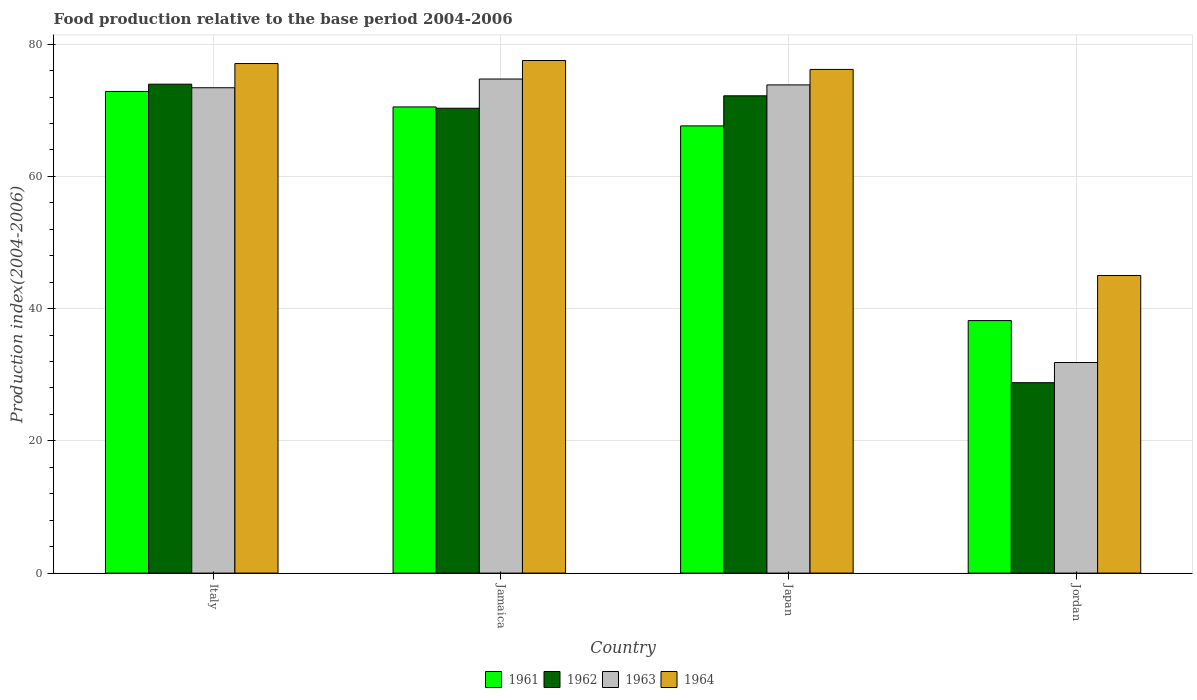How many different coloured bars are there?
Offer a terse response. 4. What is the label of the 1st group of bars from the left?
Make the answer very short. Italy. What is the food production index in 1962 in Italy?
Provide a short and direct response. 73.95. Across all countries, what is the maximum food production index in 1961?
Your response must be concise. 72.85. Across all countries, what is the minimum food production index in 1961?
Your response must be concise. 38.19. In which country was the food production index in 1963 maximum?
Your answer should be very brief. Jamaica. In which country was the food production index in 1962 minimum?
Make the answer very short. Jordan. What is the total food production index in 1961 in the graph?
Provide a short and direct response. 249.19. What is the difference between the food production index in 1961 in Japan and that in Jordan?
Ensure brevity in your answer.  29.45. What is the difference between the food production index in 1961 in Italy and the food production index in 1964 in Jordan?
Provide a short and direct response. 27.84. What is the average food production index in 1961 per country?
Provide a succinct answer. 62.3. What is the difference between the food production index of/in 1962 and food production index of/in 1964 in Japan?
Ensure brevity in your answer.  -3.99. What is the ratio of the food production index in 1962 in Italy to that in Jordan?
Ensure brevity in your answer.  2.57. Is the food production index in 1963 in Japan less than that in Jordan?
Provide a short and direct response. No. What is the difference between the highest and the second highest food production index in 1963?
Offer a very short reply. -0.43. What is the difference between the highest and the lowest food production index in 1963?
Keep it short and to the point. 42.88. In how many countries, is the food production index in 1963 greater than the average food production index in 1963 taken over all countries?
Your answer should be very brief. 3. Is the sum of the food production index in 1961 in Italy and Jordan greater than the maximum food production index in 1964 across all countries?
Offer a very short reply. Yes. Is it the case that in every country, the sum of the food production index in 1962 and food production index in 1961 is greater than the sum of food production index in 1963 and food production index in 1964?
Your answer should be compact. No. What does the 1st bar from the left in Jamaica represents?
Offer a very short reply. 1961. Is it the case that in every country, the sum of the food production index in 1962 and food production index in 1964 is greater than the food production index in 1961?
Ensure brevity in your answer.  Yes. How many bars are there?
Make the answer very short. 16. How many countries are there in the graph?
Ensure brevity in your answer.  4. Does the graph contain any zero values?
Ensure brevity in your answer.  No. Where does the legend appear in the graph?
Ensure brevity in your answer.  Bottom center. How many legend labels are there?
Your answer should be very brief. 4. How are the legend labels stacked?
Offer a very short reply. Horizontal. What is the title of the graph?
Provide a short and direct response. Food production relative to the base period 2004-2006. Does "2009" appear as one of the legend labels in the graph?
Give a very brief answer. No. What is the label or title of the X-axis?
Keep it short and to the point. Country. What is the label or title of the Y-axis?
Ensure brevity in your answer.  Production index(2004-2006). What is the Production index(2004-2006) of 1961 in Italy?
Give a very brief answer. 72.85. What is the Production index(2004-2006) in 1962 in Italy?
Offer a very short reply. 73.95. What is the Production index(2004-2006) in 1963 in Italy?
Your response must be concise. 73.41. What is the Production index(2004-2006) of 1964 in Italy?
Give a very brief answer. 77.07. What is the Production index(2004-2006) of 1961 in Jamaica?
Your answer should be very brief. 70.51. What is the Production index(2004-2006) in 1962 in Jamaica?
Keep it short and to the point. 70.31. What is the Production index(2004-2006) in 1963 in Jamaica?
Offer a very short reply. 74.73. What is the Production index(2004-2006) of 1964 in Jamaica?
Give a very brief answer. 77.53. What is the Production index(2004-2006) of 1961 in Japan?
Offer a terse response. 67.64. What is the Production index(2004-2006) in 1962 in Japan?
Keep it short and to the point. 72.19. What is the Production index(2004-2006) of 1963 in Japan?
Your response must be concise. 73.84. What is the Production index(2004-2006) of 1964 in Japan?
Your response must be concise. 76.18. What is the Production index(2004-2006) of 1961 in Jordan?
Give a very brief answer. 38.19. What is the Production index(2004-2006) in 1962 in Jordan?
Your response must be concise. 28.8. What is the Production index(2004-2006) in 1963 in Jordan?
Provide a short and direct response. 31.85. What is the Production index(2004-2006) of 1964 in Jordan?
Keep it short and to the point. 45.01. Across all countries, what is the maximum Production index(2004-2006) of 1961?
Your answer should be compact. 72.85. Across all countries, what is the maximum Production index(2004-2006) in 1962?
Keep it short and to the point. 73.95. Across all countries, what is the maximum Production index(2004-2006) in 1963?
Make the answer very short. 74.73. Across all countries, what is the maximum Production index(2004-2006) of 1964?
Make the answer very short. 77.53. Across all countries, what is the minimum Production index(2004-2006) of 1961?
Your answer should be very brief. 38.19. Across all countries, what is the minimum Production index(2004-2006) in 1962?
Provide a succinct answer. 28.8. Across all countries, what is the minimum Production index(2004-2006) of 1963?
Offer a very short reply. 31.85. Across all countries, what is the minimum Production index(2004-2006) in 1964?
Ensure brevity in your answer.  45.01. What is the total Production index(2004-2006) in 1961 in the graph?
Give a very brief answer. 249.19. What is the total Production index(2004-2006) of 1962 in the graph?
Provide a succinct answer. 245.25. What is the total Production index(2004-2006) of 1963 in the graph?
Your answer should be compact. 253.83. What is the total Production index(2004-2006) in 1964 in the graph?
Your response must be concise. 275.79. What is the difference between the Production index(2004-2006) of 1961 in Italy and that in Jamaica?
Your answer should be very brief. 2.34. What is the difference between the Production index(2004-2006) in 1962 in Italy and that in Jamaica?
Offer a terse response. 3.64. What is the difference between the Production index(2004-2006) of 1963 in Italy and that in Jamaica?
Your answer should be very brief. -1.32. What is the difference between the Production index(2004-2006) of 1964 in Italy and that in Jamaica?
Keep it short and to the point. -0.46. What is the difference between the Production index(2004-2006) in 1961 in Italy and that in Japan?
Give a very brief answer. 5.21. What is the difference between the Production index(2004-2006) of 1962 in Italy and that in Japan?
Your answer should be compact. 1.76. What is the difference between the Production index(2004-2006) in 1963 in Italy and that in Japan?
Your response must be concise. -0.43. What is the difference between the Production index(2004-2006) in 1964 in Italy and that in Japan?
Provide a succinct answer. 0.89. What is the difference between the Production index(2004-2006) in 1961 in Italy and that in Jordan?
Your response must be concise. 34.66. What is the difference between the Production index(2004-2006) of 1962 in Italy and that in Jordan?
Give a very brief answer. 45.15. What is the difference between the Production index(2004-2006) in 1963 in Italy and that in Jordan?
Give a very brief answer. 41.56. What is the difference between the Production index(2004-2006) of 1964 in Italy and that in Jordan?
Your answer should be very brief. 32.06. What is the difference between the Production index(2004-2006) of 1961 in Jamaica and that in Japan?
Your answer should be very brief. 2.87. What is the difference between the Production index(2004-2006) of 1962 in Jamaica and that in Japan?
Provide a succinct answer. -1.88. What is the difference between the Production index(2004-2006) in 1963 in Jamaica and that in Japan?
Your response must be concise. 0.89. What is the difference between the Production index(2004-2006) of 1964 in Jamaica and that in Japan?
Make the answer very short. 1.35. What is the difference between the Production index(2004-2006) in 1961 in Jamaica and that in Jordan?
Your answer should be very brief. 32.32. What is the difference between the Production index(2004-2006) of 1962 in Jamaica and that in Jordan?
Offer a terse response. 41.51. What is the difference between the Production index(2004-2006) of 1963 in Jamaica and that in Jordan?
Your response must be concise. 42.88. What is the difference between the Production index(2004-2006) in 1964 in Jamaica and that in Jordan?
Your answer should be very brief. 32.52. What is the difference between the Production index(2004-2006) of 1961 in Japan and that in Jordan?
Ensure brevity in your answer.  29.45. What is the difference between the Production index(2004-2006) in 1962 in Japan and that in Jordan?
Offer a terse response. 43.39. What is the difference between the Production index(2004-2006) in 1963 in Japan and that in Jordan?
Offer a very short reply. 41.99. What is the difference between the Production index(2004-2006) in 1964 in Japan and that in Jordan?
Offer a terse response. 31.17. What is the difference between the Production index(2004-2006) of 1961 in Italy and the Production index(2004-2006) of 1962 in Jamaica?
Give a very brief answer. 2.54. What is the difference between the Production index(2004-2006) of 1961 in Italy and the Production index(2004-2006) of 1963 in Jamaica?
Give a very brief answer. -1.88. What is the difference between the Production index(2004-2006) in 1961 in Italy and the Production index(2004-2006) in 1964 in Jamaica?
Offer a terse response. -4.68. What is the difference between the Production index(2004-2006) of 1962 in Italy and the Production index(2004-2006) of 1963 in Jamaica?
Offer a very short reply. -0.78. What is the difference between the Production index(2004-2006) of 1962 in Italy and the Production index(2004-2006) of 1964 in Jamaica?
Keep it short and to the point. -3.58. What is the difference between the Production index(2004-2006) in 1963 in Italy and the Production index(2004-2006) in 1964 in Jamaica?
Offer a terse response. -4.12. What is the difference between the Production index(2004-2006) of 1961 in Italy and the Production index(2004-2006) of 1962 in Japan?
Provide a succinct answer. 0.66. What is the difference between the Production index(2004-2006) in 1961 in Italy and the Production index(2004-2006) in 1963 in Japan?
Your answer should be compact. -0.99. What is the difference between the Production index(2004-2006) in 1961 in Italy and the Production index(2004-2006) in 1964 in Japan?
Provide a short and direct response. -3.33. What is the difference between the Production index(2004-2006) in 1962 in Italy and the Production index(2004-2006) in 1963 in Japan?
Offer a terse response. 0.11. What is the difference between the Production index(2004-2006) in 1962 in Italy and the Production index(2004-2006) in 1964 in Japan?
Give a very brief answer. -2.23. What is the difference between the Production index(2004-2006) of 1963 in Italy and the Production index(2004-2006) of 1964 in Japan?
Provide a succinct answer. -2.77. What is the difference between the Production index(2004-2006) in 1961 in Italy and the Production index(2004-2006) in 1962 in Jordan?
Make the answer very short. 44.05. What is the difference between the Production index(2004-2006) of 1961 in Italy and the Production index(2004-2006) of 1964 in Jordan?
Provide a short and direct response. 27.84. What is the difference between the Production index(2004-2006) in 1962 in Italy and the Production index(2004-2006) in 1963 in Jordan?
Your answer should be very brief. 42.1. What is the difference between the Production index(2004-2006) in 1962 in Italy and the Production index(2004-2006) in 1964 in Jordan?
Your answer should be compact. 28.94. What is the difference between the Production index(2004-2006) in 1963 in Italy and the Production index(2004-2006) in 1964 in Jordan?
Your answer should be compact. 28.4. What is the difference between the Production index(2004-2006) of 1961 in Jamaica and the Production index(2004-2006) of 1962 in Japan?
Give a very brief answer. -1.68. What is the difference between the Production index(2004-2006) in 1961 in Jamaica and the Production index(2004-2006) in 1963 in Japan?
Your answer should be compact. -3.33. What is the difference between the Production index(2004-2006) in 1961 in Jamaica and the Production index(2004-2006) in 1964 in Japan?
Your answer should be very brief. -5.67. What is the difference between the Production index(2004-2006) of 1962 in Jamaica and the Production index(2004-2006) of 1963 in Japan?
Your answer should be compact. -3.53. What is the difference between the Production index(2004-2006) of 1962 in Jamaica and the Production index(2004-2006) of 1964 in Japan?
Provide a short and direct response. -5.87. What is the difference between the Production index(2004-2006) in 1963 in Jamaica and the Production index(2004-2006) in 1964 in Japan?
Your answer should be compact. -1.45. What is the difference between the Production index(2004-2006) in 1961 in Jamaica and the Production index(2004-2006) in 1962 in Jordan?
Provide a succinct answer. 41.71. What is the difference between the Production index(2004-2006) in 1961 in Jamaica and the Production index(2004-2006) in 1963 in Jordan?
Give a very brief answer. 38.66. What is the difference between the Production index(2004-2006) in 1961 in Jamaica and the Production index(2004-2006) in 1964 in Jordan?
Keep it short and to the point. 25.5. What is the difference between the Production index(2004-2006) in 1962 in Jamaica and the Production index(2004-2006) in 1963 in Jordan?
Offer a very short reply. 38.46. What is the difference between the Production index(2004-2006) of 1962 in Jamaica and the Production index(2004-2006) of 1964 in Jordan?
Give a very brief answer. 25.3. What is the difference between the Production index(2004-2006) of 1963 in Jamaica and the Production index(2004-2006) of 1964 in Jordan?
Provide a succinct answer. 29.72. What is the difference between the Production index(2004-2006) in 1961 in Japan and the Production index(2004-2006) in 1962 in Jordan?
Your answer should be compact. 38.84. What is the difference between the Production index(2004-2006) of 1961 in Japan and the Production index(2004-2006) of 1963 in Jordan?
Offer a terse response. 35.79. What is the difference between the Production index(2004-2006) of 1961 in Japan and the Production index(2004-2006) of 1964 in Jordan?
Your answer should be very brief. 22.63. What is the difference between the Production index(2004-2006) in 1962 in Japan and the Production index(2004-2006) in 1963 in Jordan?
Offer a very short reply. 40.34. What is the difference between the Production index(2004-2006) in 1962 in Japan and the Production index(2004-2006) in 1964 in Jordan?
Offer a very short reply. 27.18. What is the difference between the Production index(2004-2006) in 1963 in Japan and the Production index(2004-2006) in 1964 in Jordan?
Keep it short and to the point. 28.83. What is the average Production index(2004-2006) in 1961 per country?
Your answer should be compact. 62.3. What is the average Production index(2004-2006) of 1962 per country?
Provide a short and direct response. 61.31. What is the average Production index(2004-2006) of 1963 per country?
Your answer should be compact. 63.46. What is the average Production index(2004-2006) of 1964 per country?
Your answer should be compact. 68.95. What is the difference between the Production index(2004-2006) of 1961 and Production index(2004-2006) of 1962 in Italy?
Make the answer very short. -1.1. What is the difference between the Production index(2004-2006) in 1961 and Production index(2004-2006) in 1963 in Italy?
Your answer should be compact. -0.56. What is the difference between the Production index(2004-2006) of 1961 and Production index(2004-2006) of 1964 in Italy?
Provide a succinct answer. -4.22. What is the difference between the Production index(2004-2006) of 1962 and Production index(2004-2006) of 1963 in Italy?
Your answer should be compact. 0.54. What is the difference between the Production index(2004-2006) of 1962 and Production index(2004-2006) of 1964 in Italy?
Provide a short and direct response. -3.12. What is the difference between the Production index(2004-2006) of 1963 and Production index(2004-2006) of 1964 in Italy?
Provide a succinct answer. -3.66. What is the difference between the Production index(2004-2006) in 1961 and Production index(2004-2006) in 1963 in Jamaica?
Make the answer very short. -4.22. What is the difference between the Production index(2004-2006) of 1961 and Production index(2004-2006) of 1964 in Jamaica?
Offer a very short reply. -7.02. What is the difference between the Production index(2004-2006) of 1962 and Production index(2004-2006) of 1963 in Jamaica?
Your response must be concise. -4.42. What is the difference between the Production index(2004-2006) in 1962 and Production index(2004-2006) in 1964 in Jamaica?
Provide a short and direct response. -7.22. What is the difference between the Production index(2004-2006) of 1963 and Production index(2004-2006) of 1964 in Jamaica?
Your response must be concise. -2.8. What is the difference between the Production index(2004-2006) of 1961 and Production index(2004-2006) of 1962 in Japan?
Offer a very short reply. -4.55. What is the difference between the Production index(2004-2006) in 1961 and Production index(2004-2006) in 1964 in Japan?
Ensure brevity in your answer.  -8.54. What is the difference between the Production index(2004-2006) in 1962 and Production index(2004-2006) in 1963 in Japan?
Your response must be concise. -1.65. What is the difference between the Production index(2004-2006) in 1962 and Production index(2004-2006) in 1964 in Japan?
Offer a very short reply. -3.99. What is the difference between the Production index(2004-2006) of 1963 and Production index(2004-2006) of 1964 in Japan?
Provide a short and direct response. -2.34. What is the difference between the Production index(2004-2006) in 1961 and Production index(2004-2006) in 1962 in Jordan?
Your answer should be very brief. 9.39. What is the difference between the Production index(2004-2006) of 1961 and Production index(2004-2006) of 1963 in Jordan?
Offer a very short reply. 6.34. What is the difference between the Production index(2004-2006) of 1961 and Production index(2004-2006) of 1964 in Jordan?
Provide a succinct answer. -6.82. What is the difference between the Production index(2004-2006) of 1962 and Production index(2004-2006) of 1963 in Jordan?
Ensure brevity in your answer.  -3.05. What is the difference between the Production index(2004-2006) in 1962 and Production index(2004-2006) in 1964 in Jordan?
Provide a succinct answer. -16.21. What is the difference between the Production index(2004-2006) of 1963 and Production index(2004-2006) of 1964 in Jordan?
Ensure brevity in your answer.  -13.16. What is the ratio of the Production index(2004-2006) in 1961 in Italy to that in Jamaica?
Give a very brief answer. 1.03. What is the ratio of the Production index(2004-2006) of 1962 in Italy to that in Jamaica?
Offer a terse response. 1.05. What is the ratio of the Production index(2004-2006) of 1963 in Italy to that in Jamaica?
Offer a very short reply. 0.98. What is the ratio of the Production index(2004-2006) of 1964 in Italy to that in Jamaica?
Your answer should be compact. 0.99. What is the ratio of the Production index(2004-2006) in 1961 in Italy to that in Japan?
Keep it short and to the point. 1.08. What is the ratio of the Production index(2004-2006) of 1962 in Italy to that in Japan?
Keep it short and to the point. 1.02. What is the ratio of the Production index(2004-2006) in 1964 in Italy to that in Japan?
Keep it short and to the point. 1.01. What is the ratio of the Production index(2004-2006) of 1961 in Italy to that in Jordan?
Provide a short and direct response. 1.91. What is the ratio of the Production index(2004-2006) in 1962 in Italy to that in Jordan?
Ensure brevity in your answer.  2.57. What is the ratio of the Production index(2004-2006) in 1963 in Italy to that in Jordan?
Offer a terse response. 2.3. What is the ratio of the Production index(2004-2006) of 1964 in Italy to that in Jordan?
Offer a terse response. 1.71. What is the ratio of the Production index(2004-2006) in 1961 in Jamaica to that in Japan?
Ensure brevity in your answer.  1.04. What is the ratio of the Production index(2004-2006) in 1963 in Jamaica to that in Japan?
Offer a very short reply. 1.01. What is the ratio of the Production index(2004-2006) in 1964 in Jamaica to that in Japan?
Make the answer very short. 1.02. What is the ratio of the Production index(2004-2006) in 1961 in Jamaica to that in Jordan?
Your answer should be compact. 1.85. What is the ratio of the Production index(2004-2006) in 1962 in Jamaica to that in Jordan?
Ensure brevity in your answer.  2.44. What is the ratio of the Production index(2004-2006) in 1963 in Jamaica to that in Jordan?
Your answer should be compact. 2.35. What is the ratio of the Production index(2004-2006) in 1964 in Jamaica to that in Jordan?
Your answer should be very brief. 1.72. What is the ratio of the Production index(2004-2006) in 1961 in Japan to that in Jordan?
Provide a short and direct response. 1.77. What is the ratio of the Production index(2004-2006) of 1962 in Japan to that in Jordan?
Provide a short and direct response. 2.51. What is the ratio of the Production index(2004-2006) of 1963 in Japan to that in Jordan?
Ensure brevity in your answer.  2.32. What is the ratio of the Production index(2004-2006) in 1964 in Japan to that in Jordan?
Your answer should be compact. 1.69. What is the difference between the highest and the second highest Production index(2004-2006) of 1961?
Offer a terse response. 2.34. What is the difference between the highest and the second highest Production index(2004-2006) of 1962?
Make the answer very short. 1.76. What is the difference between the highest and the second highest Production index(2004-2006) of 1963?
Make the answer very short. 0.89. What is the difference between the highest and the second highest Production index(2004-2006) of 1964?
Your answer should be compact. 0.46. What is the difference between the highest and the lowest Production index(2004-2006) in 1961?
Provide a succinct answer. 34.66. What is the difference between the highest and the lowest Production index(2004-2006) in 1962?
Make the answer very short. 45.15. What is the difference between the highest and the lowest Production index(2004-2006) of 1963?
Your response must be concise. 42.88. What is the difference between the highest and the lowest Production index(2004-2006) of 1964?
Give a very brief answer. 32.52. 